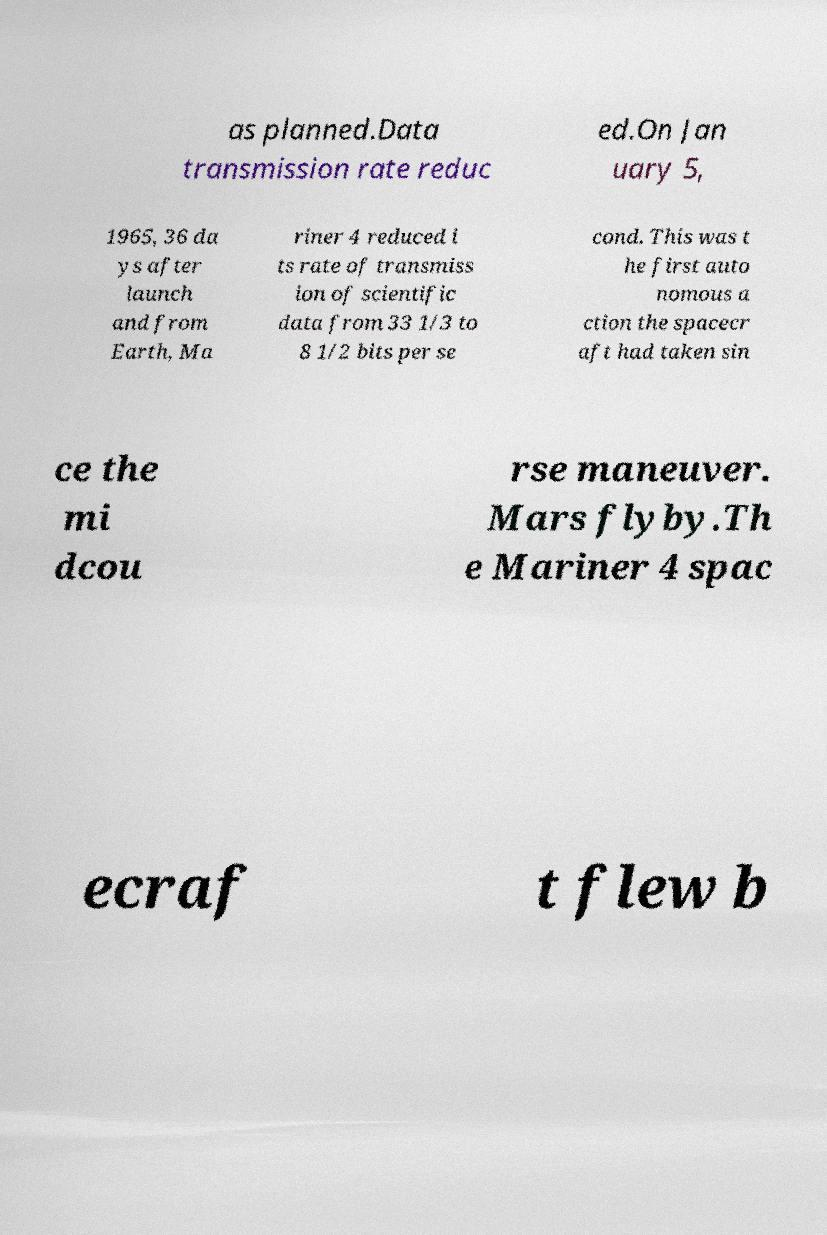Could you assist in decoding the text presented in this image and type it out clearly? as planned.Data transmission rate reduc ed.On Jan uary 5, 1965, 36 da ys after launch and from Earth, Ma riner 4 reduced i ts rate of transmiss ion of scientific data from 33 1/3 to 8 1/2 bits per se cond. This was t he first auto nomous a ction the spacecr aft had taken sin ce the mi dcou rse maneuver. Mars flyby.Th e Mariner 4 spac ecraf t flew b 